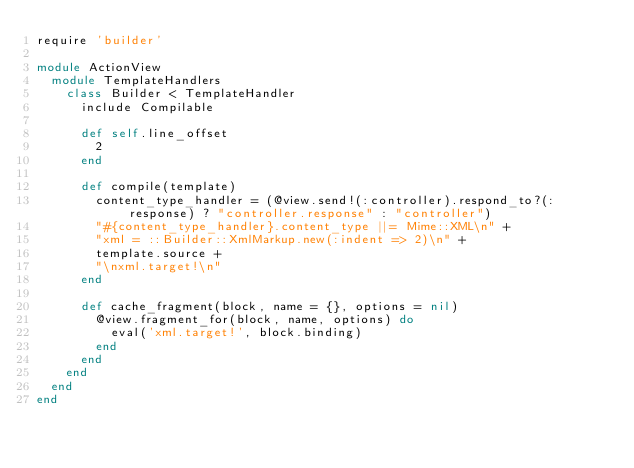Convert code to text. <code><loc_0><loc_0><loc_500><loc_500><_Ruby_>require 'builder'

module ActionView
  module TemplateHandlers
    class Builder < TemplateHandler
      include Compilable

      def self.line_offset
        2
      end

      def compile(template)
        content_type_handler = (@view.send!(:controller).respond_to?(:response) ? "controller.response" : "controller")
        "#{content_type_handler}.content_type ||= Mime::XML\n" +
        "xml = ::Builder::XmlMarkup.new(:indent => 2)\n" +
        template.source +
        "\nxml.target!\n"
      end

      def cache_fragment(block, name = {}, options = nil)
        @view.fragment_for(block, name, options) do
          eval('xml.target!', block.binding)
        end
      end
    end
  end
end
</code> 